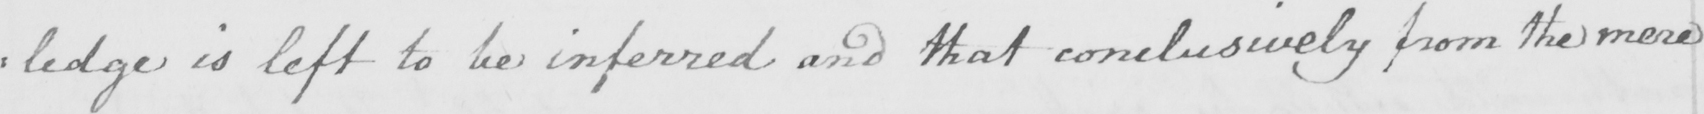Please provide the text content of this handwritten line. : ledge is left to be inferred and that conclusively from the mere 